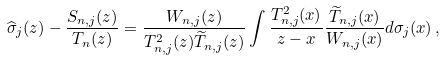<formula> <loc_0><loc_0><loc_500><loc_500>\widehat { \sigma } _ { j } ( z ) - \frac { S _ { { n } , j } ( z ) } { T _ { n } ( z ) } = \frac { W _ { { n } , j } ( z ) } { T _ { { n } , j } ^ { 2 } ( z ) \widetilde { T } _ { { n } , j } ( z ) } \int \frac { T _ { { n } , j } ^ { 2 } ( x ) } { z - x } \frac { \widetilde { T } _ { { n } , j } ( x ) } { W _ { { n } , j } ( x ) } d \sigma _ { j } ( x ) \, ,</formula> 